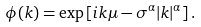<formula> <loc_0><loc_0><loc_500><loc_500>\phi ( k ) = \exp \left [ i k \mu - \sigma ^ { \alpha } | k | ^ { \alpha } \right ] .</formula> 